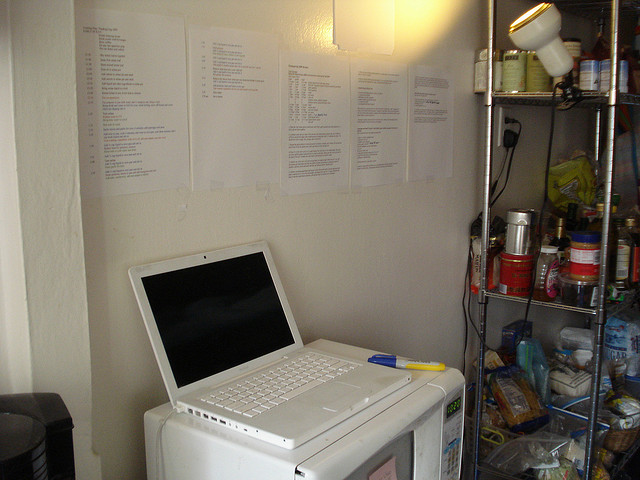Is there a coffee maker in the image? Yes, there is a coffee maker seen at the bottom left corner of the image. 